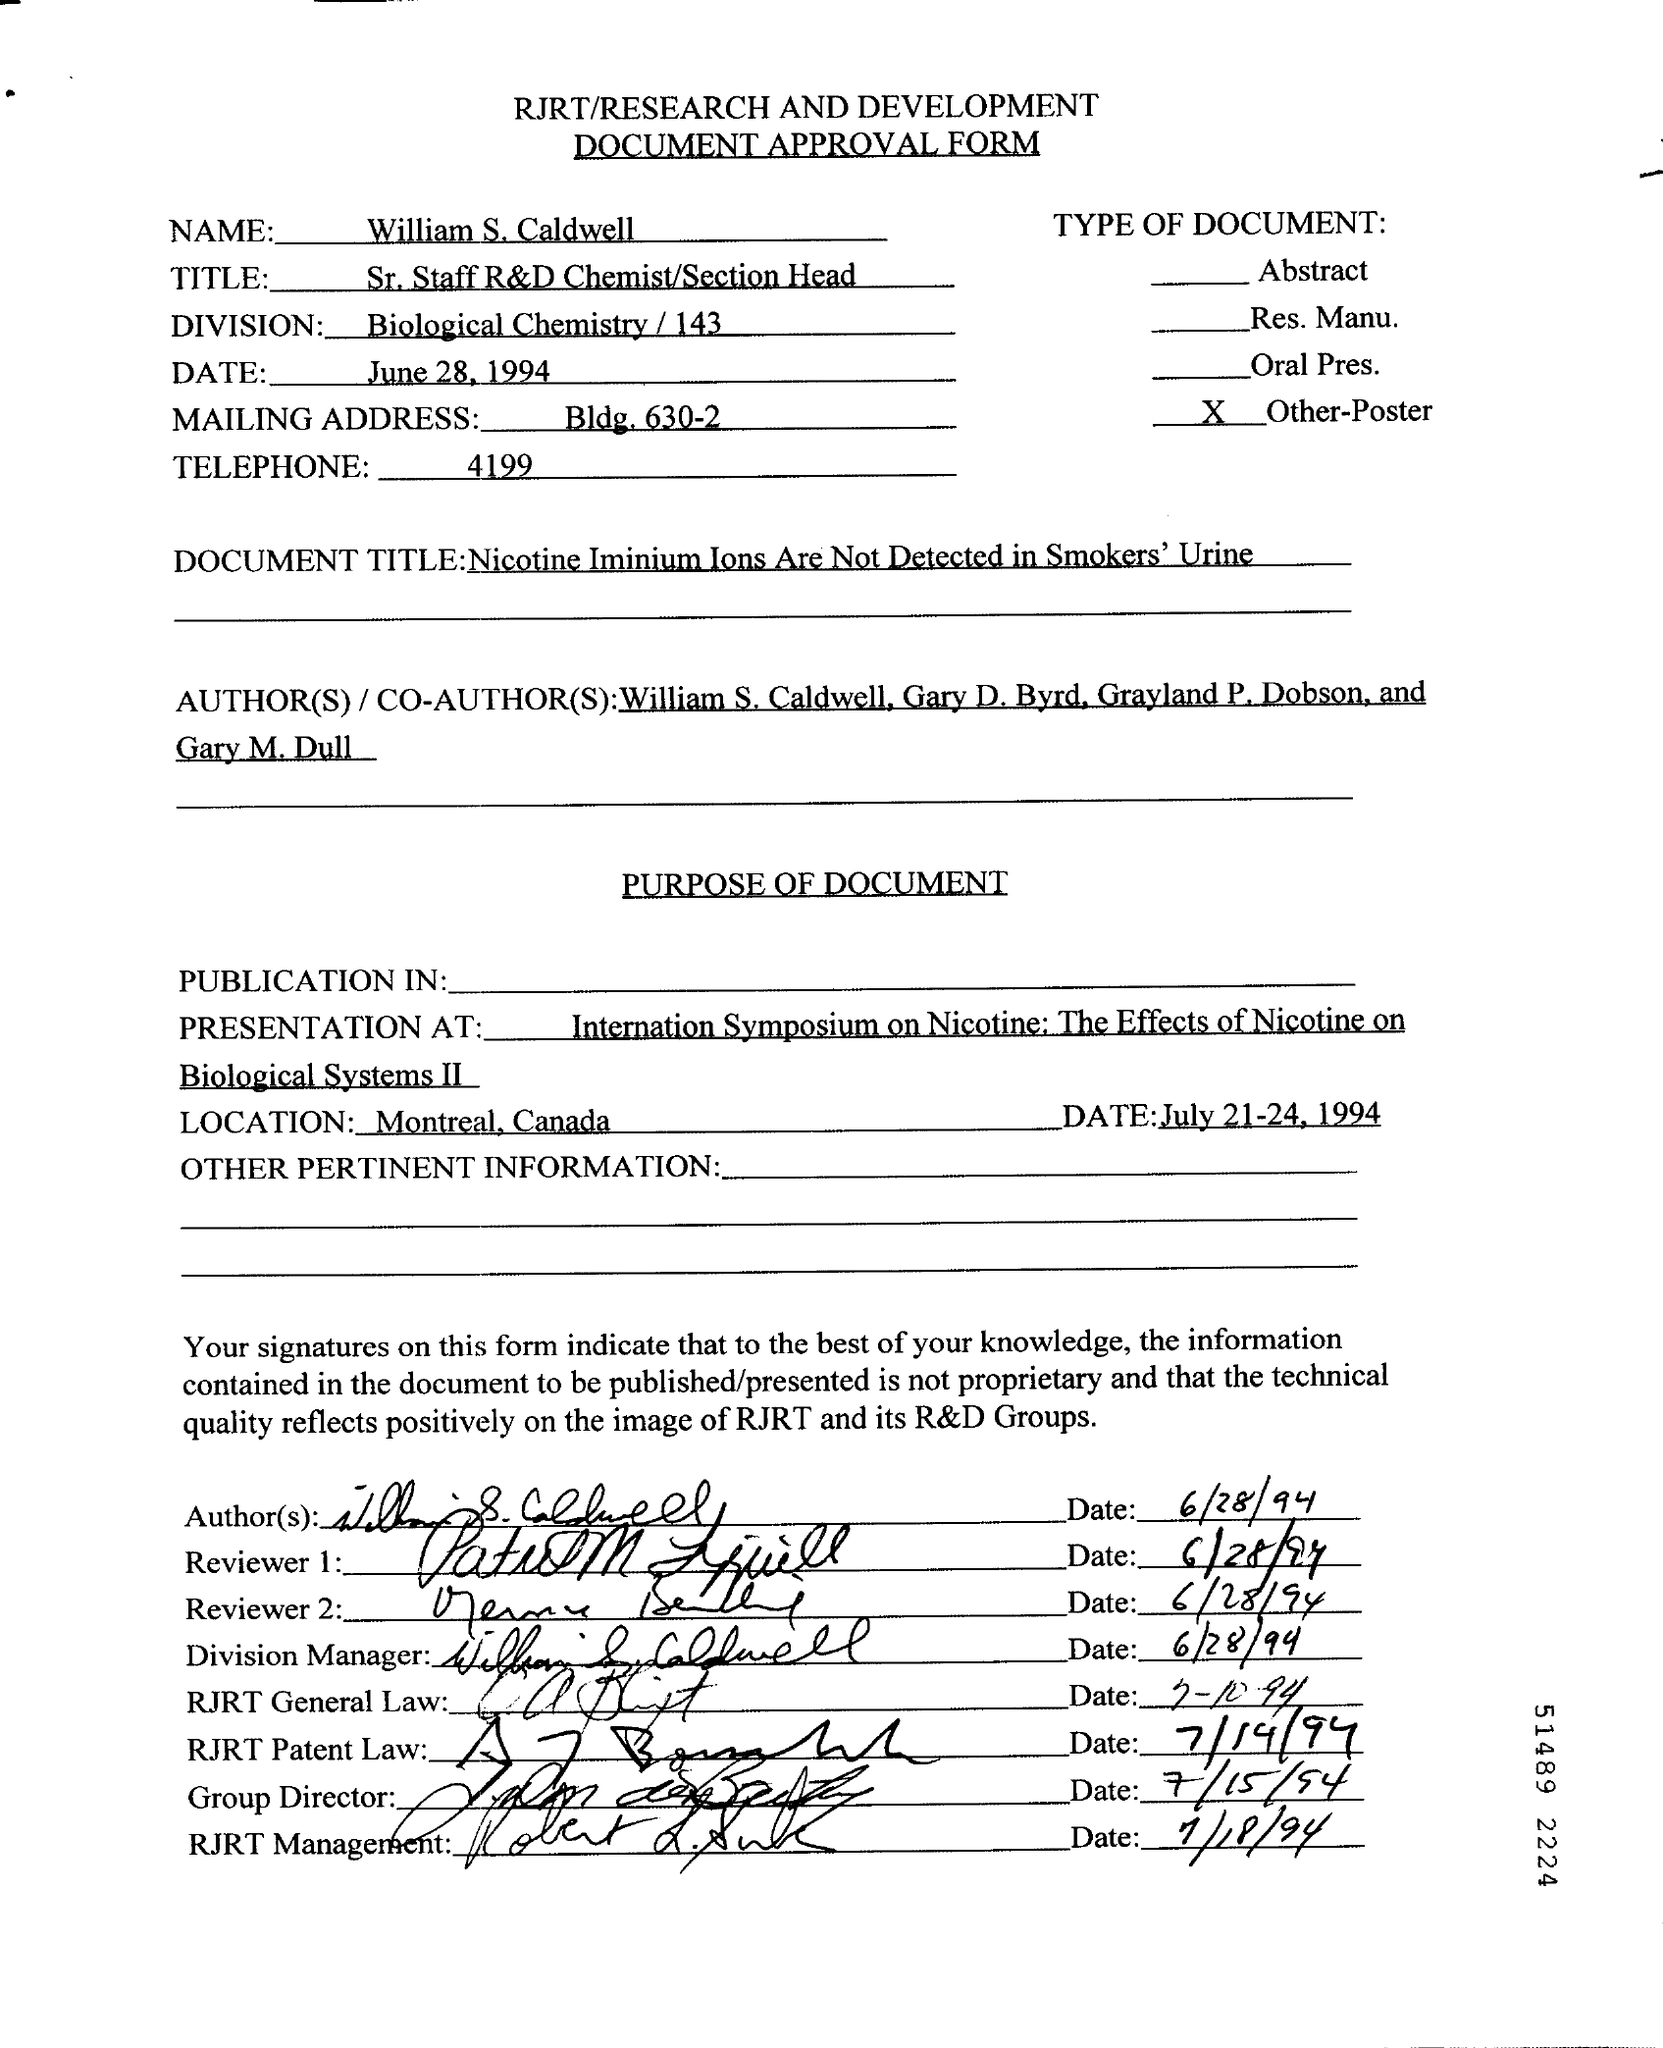Draw attention to some important aspects in this diagram. The date mentioned at the top of the document is June 28, 1994. The location is Montreal. The telephone number is 4199... The Division field contains the written text "Biological Chemistry / 143...". 